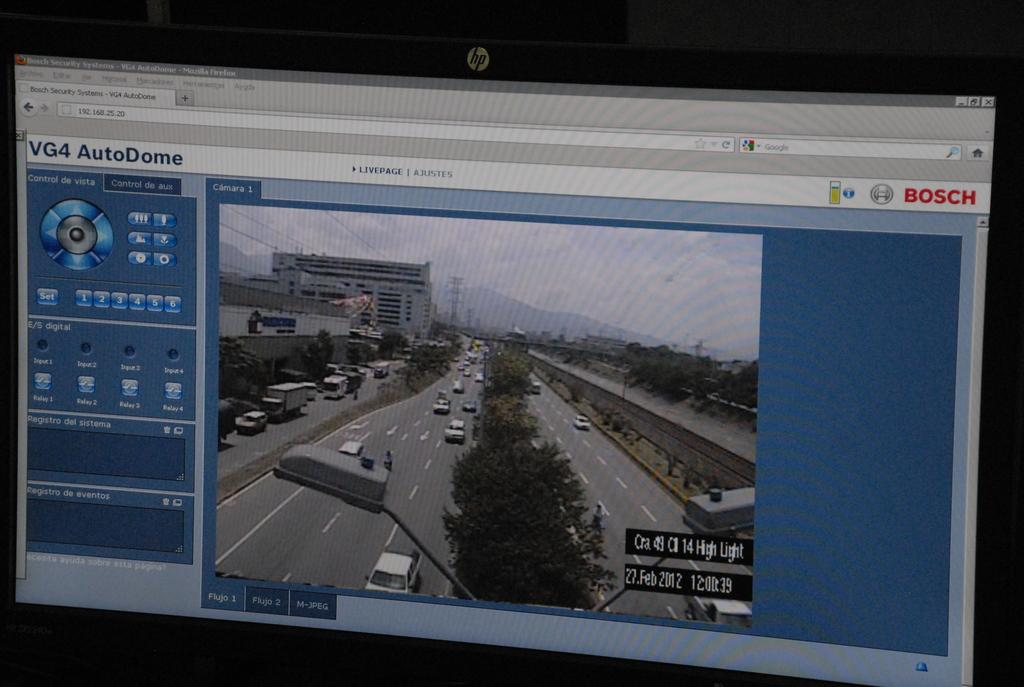<image>
Offer a succinct explanation of the picture presented. Computer screen showing the traffic and the word BOSCH on it. 